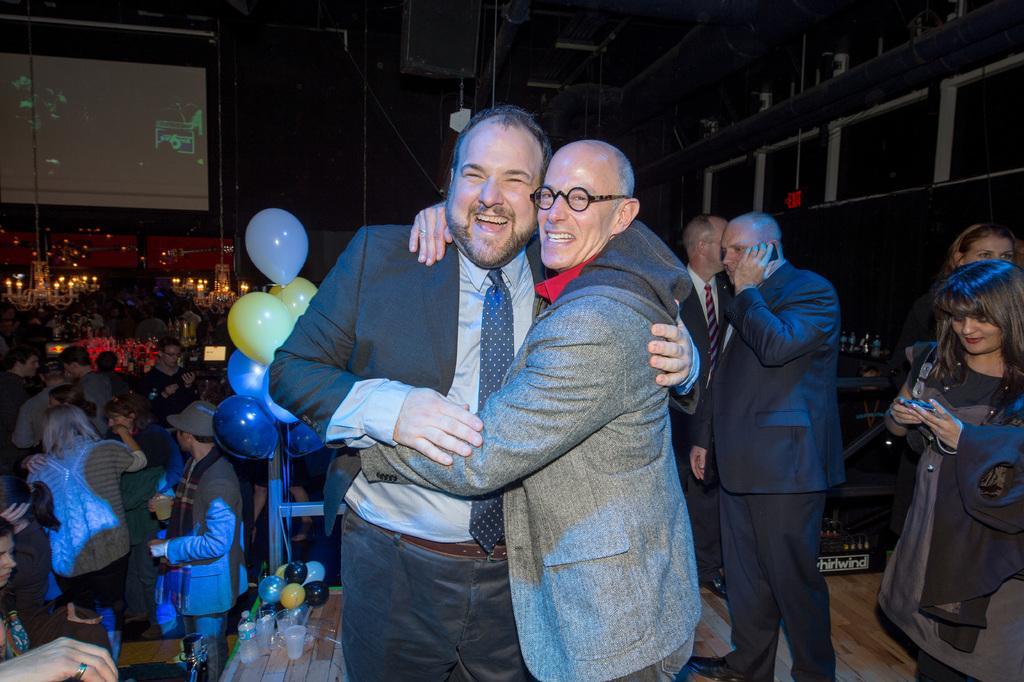In one or two sentences, can you explain what this image depicts? In this image in the foreground there are two people standing, and they are hugging each other. And in the background there are a group of people, balloons, glasses, tables, board, lights, wall, speaker and some objects. At the bottom there is floor. 